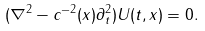<formula> <loc_0><loc_0><loc_500><loc_500>( \nabla ^ { 2 } - c ^ { - 2 } ( x ) \partial _ { t } ^ { 2 } ) U ( t , x ) = 0 .</formula> 